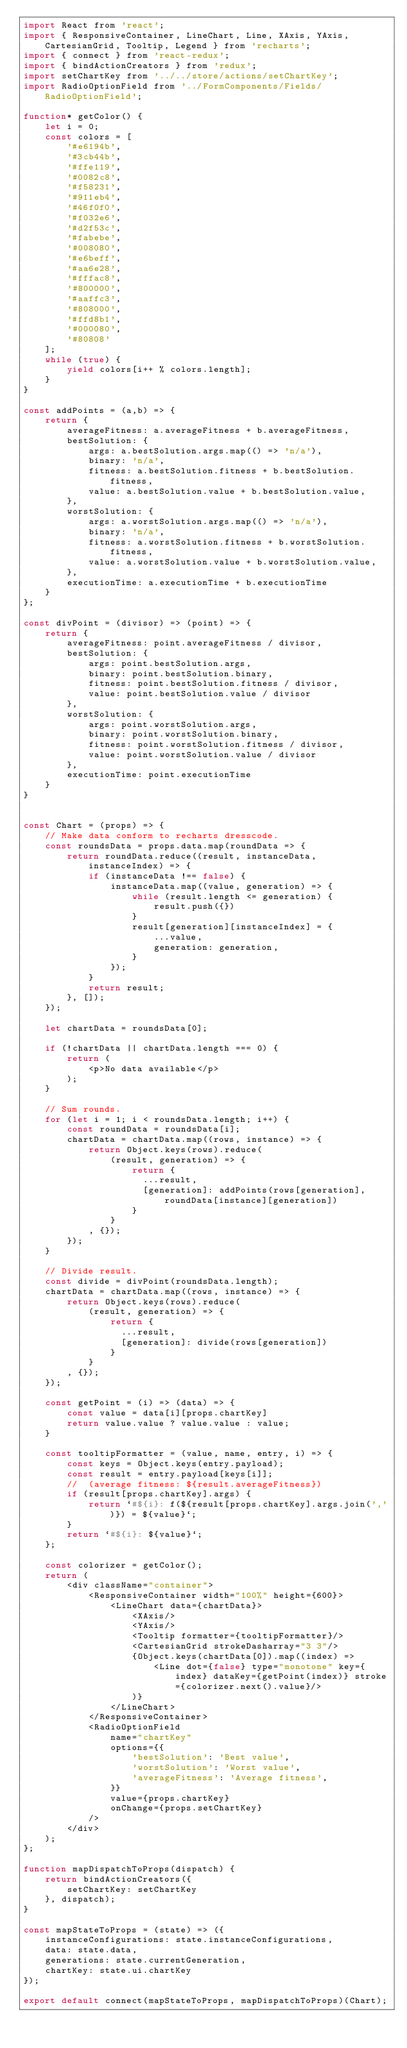Convert code to text. <code><loc_0><loc_0><loc_500><loc_500><_JavaScript_>import React from 'react';
import { ResponsiveContainer, LineChart, Line, XAxis, YAxis, CartesianGrid, Tooltip, Legend } from 'recharts';
import { connect } from 'react-redux';
import { bindActionCreators } from 'redux';
import setChartKey from '../../store/actions/setChartKey';
import RadioOptionField from '../FormComponents/Fields/RadioOptionField';

function* getColor() {
    let i = 0;
    const colors = [
        '#e6194b',
        '#3cb44b',
        '#ffe119',
        '#0082c8',
        '#f58231',
        '#911eb4',
        '#46f0f0',
        '#f032e6',
        '#d2f53c',
        '#fabebe',
        '#008080',
        '#e6beff',
        '#aa6e28',
        '#fffac8',
        '#800000',
        '#aaffc3',
        '#808000',
        '#ffd8b1',
        '#000080',
        '#80808'
    ];
    while (true) {
        yield colors[i++ % colors.length];
    }
} 

const addPoints = (a,b) => {
    return {
        averageFitness: a.averageFitness + b.averageFitness,
        bestSolution: {
            args: a.bestSolution.args.map(() => 'n/a'),
            binary: 'n/a',
            fitness: a.bestSolution.fitness + b.bestSolution.fitness,
            value: a.bestSolution.value + b.bestSolution.value,
        },
        worstSolution: {
            args: a.worstSolution.args.map(() => 'n/a'),
            binary: 'n/a',
            fitness: a.worstSolution.fitness + b.worstSolution.fitness,
            value: a.worstSolution.value + b.worstSolution.value,
        },
        executionTime: a.executionTime + b.executionTime
    }
};

const divPoint = (divisor) => (point) => {
    return {
        averageFitness: point.averageFitness / divisor,
        bestSolution: {
            args: point.bestSolution.args,
            binary: point.bestSolution.binary,
            fitness: point.bestSolution.fitness / divisor,
            value: point.bestSolution.value / divisor
        },
        worstSolution: {
            args: point.worstSolution.args,
            binary: point.worstSolution.binary,
            fitness: point.worstSolution.fitness / divisor,
            value: point.worstSolution.value / divisor
        },
        executionTime: point.executionTime
    }
}


const Chart = (props) => {
    // Make data conform to recharts dresscode.
    const roundsData = props.data.map(roundData => {
        return roundData.reduce((result, instanceData, instanceIndex) => {
            if (instanceData !== false) {
                instanceData.map((value, generation) => {
                    while (result.length <= generation) {
                        result.push({})
                    }
                    result[generation][instanceIndex] = {
                        ...value,
                        generation: generation,
                    }
                });
            }
            return result;
        }, []);
    });

    let chartData = roundsData[0];

    if (!chartData || chartData.length === 0) {
        return (
            <p>No data available</p>
        );
    }

    // Sum rounds.
    for (let i = 1; i < roundsData.length; i++) {
        const roundData = roundsData[i];
        chartData = chartData.map((rows, instance) => {
            return Object.keys(rows).reduce(
                (result, generation) => {
                    return { 
                      ...result,
                      [generation]: addPoints(rows[generation], roundData[instance][generation])
                    }
                }
            , {});
        });
    }

    // Divide result.
    const divide = divPoint(roundsData.length);
    chartData = chartData.map((rows, instance) => {
        return Object.keys(rows).reduce(
            (result, generation) => {
                return { 
                  ...result,
                  [generation]: divide(rows[generation])
                }
            }
        , {});
    });

    const getPoint = (i) => (data) => {
        const value = data[i][props.chartKey]
        return value.value ? value.value : value;
    }

    const tooltipFormatter = (value, name, entry, i) => {
        const keys = Object.keys(entry.payload);
        const result = entry.payload[keys[i]];
        //  (average fitness: ${result.averageFitness})
        if (result[props.chartKey].args) {
            return `#${i}: f(${result[props.chartKey].args.join(',')}) = ${value}`;
        }
        return `#${i}: ${value}`;
    };

    const colorizer = getColor();
    return (
        <div className="container">
            <ResponsiveContainer width="100%" height={600}>
                <LineChart data={chartData}>
                    <XAxis/>
                    <YAxis/>
                    <Tooltip formatter={tooltipFormatter}/>
                    <CartesianGrid strokeDasharray="3 3"/>
                    {Object.keys(chartData[0]).map((index) =>
                        <Line dot={false} type="monotone" key={index} dataKey={getPoint(index)} stroke={colorizer.next().value}/>
                    )}            
                </LineChart>
            </ResponsiveContainer>
            <RadioOptionField
                name="chartKey"
                options={{
                    'bestSolution': 'Best value',
                    'worstSolution': 'Worst value',
                    'averageFitness': 'Average fitness',
                }}
                value={props.chartKey}
                onChange={props.setChartKey}
            />
        </div>
    );
};

function mapDispatchToProps(dispatch) {
    return bindActionCreators({
        setChartKey: setChartKey
    }, dispatch);
}

const mapStateToProps = (state) => ({
    instanceConfigurations: state.instanceConfigurations,
    data: state.data,
    generations: state.currentGeneration,
    chartKey: state.ui.chartKey
});

export default connect(mapStateToProps, mapDispatchToProps)(Chart);</code> 